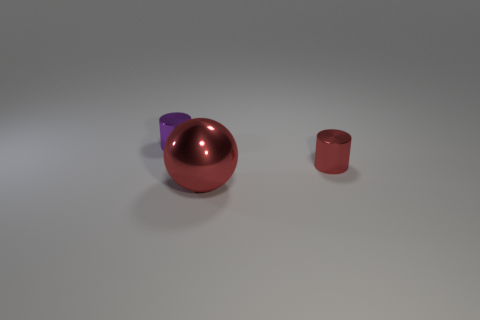There is a small object that is in front of the purple metallic thing; is its shape the same as the large red object?
Provide a short and direct response. No. Are there more red metallic spheres in front of the tiny red cylinder than large cyan metal blocks?
Provide a short and direct response. Yes. How many red shiny things are the same size as the purple metallic object?
Offer a very short reply. 1. How many things are tiny brown cylinders or spheres that are to the left of the tiny red cylinder?
Your response must be concise. 1. The object that is both to the left of the tiny red cylinder and behind the sphere is what color?
Give a very brief answer. Purple. Does the red cylinder have the same size as the ball?
Keep it short and to the point. No. What color is the metallic cylinder on the left side of the small red metallic cylinder?
Give a very brief answer. Purple. Are there any small metallic cylinders that have the same color as the large object?
Provide a short and direct response. Yes. There is another object that is the same size as the purple metal thing; what color is it?
Offer a terse response. Red. Is the small purple object the same shape as the small red shiny object?
Keep it short and to the point. Yes. 